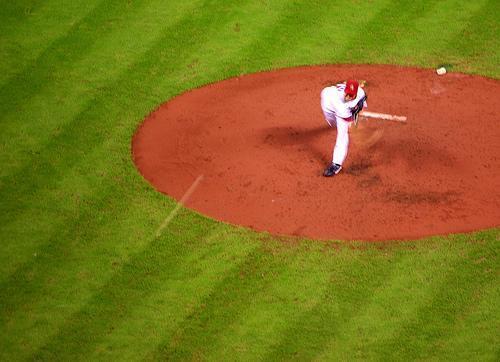How many men are in this picture?
Give a very brief answer. 1. How many people are pictured here?
Give a very brief answer. 1. 